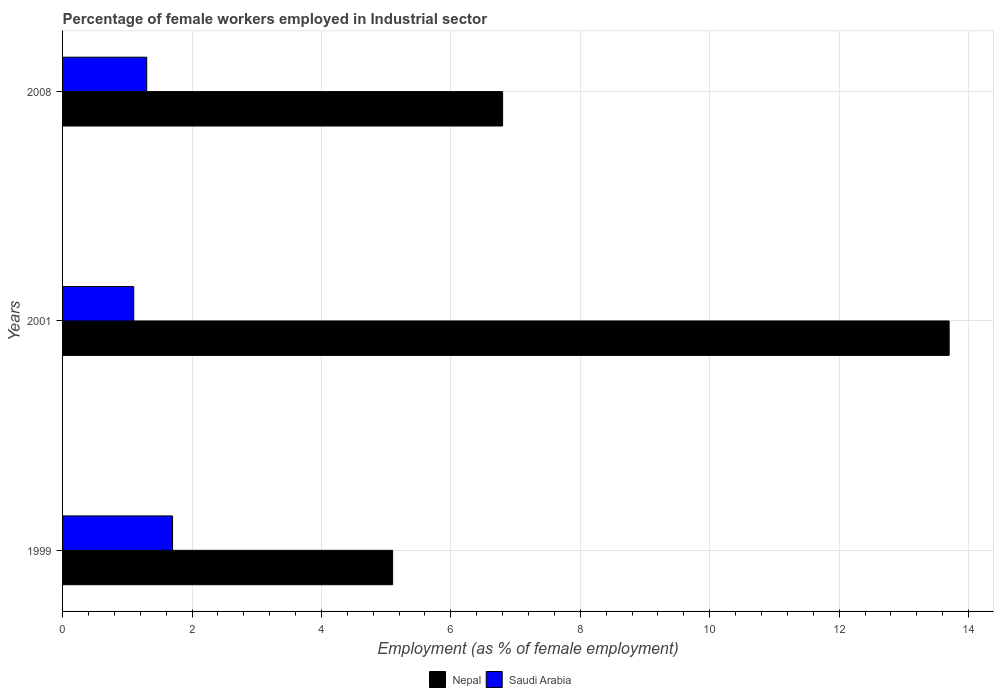How many different coloured bars are there?
Provide a succinct answer. 2. How many groups of bars are there?
Make the answer very short. 3. Are the number of bars per tick equal to the number of legend labels?
Make the answer very short. Yes. Are the number of bars on each tick of the Y-axis equal?
Offer a terse response. Yes. How many bars are there on the 2nd tick from the top?
Your answer should be compact. 2. How many bars are there on the 1st tick from the bottom?
Your answer should be very brief. 2. What is the label of the 3rd group of bars from the top?
Ensure brevity in your answer.  1999. In how many cases, is the number of bars for a given year not equal to the number of legend labels?
Your answer should be compact. 0. What is the percentage of females employed in Industrial sector in Saudi Arabia in 2008?
Your response must be concise. 1.3. Across all years, what is the maximum percentage of females employed in Industrial sector in Nepal?
Your answer should be compact. 13.7. Across all years, what is the minimum percentage of females employed in Industrial sector in Nepal?
Keep it short and to the point. 5.1. In which year was the percentage of females employed in Industrial sector in Nepal minimum?
Your answer should be compact. 1999. What is the total percentage of females employed in Industrial sector in Saudi Arabia in the graph?
Ensure brevity in your answer.  4.1. What is the difference between the percentage of females employed in Industrial sector in Saudi Arabia in 1999 and that in 2001?
Offer a terse response. 0.6. What is the difference between the percentage of females employed in Industrial sector in Saudi Arabia in 2008 and the percentage of females employed in Industrial sector in Nepal in 2001?
Give a very brief answer. -12.4. What is the average percentage of females employed in Industrial sector in Nepal per year?
Your answer should be very brief. 8.53. In the year 2008, what is the difference between the percentage of females employed in Industrial sector in Nepal and percentage of females employed in Industrial sector in Saudi Arabia?
Keep it short and to the point. 5.5. In how many years, is the percentage of females employed in Industrial sector in Saudi Arabia greater than 1.2000000000000002 %?
Provide a short and direct response. 2. What is the ratio of the percentage of females employed in Industrial sector in Saudi Arabia in 1999 to that in 2008?
Provide a succinct answer. 1.31. What is the difference between the highest and the second highest percentage of females employed in Industrial sector in Saudi Arabia?
Give a very brief answer. 0.4. What is the difference between the highest and the lowest percentage of females employed in Industrial sector in Nepal?
Your answer should be very brief. 8.6. Is the sum of the percentage of females employed in Industrial sector in Nepal in 2001 and 2008 greater than the maximum percentage of females employed in Industrial sector in Saudi Arabia across all years?
Offer a very short reply. Yes. What does the 2nd bar from the top in 2008 represents?
Provide a short and direct response. Nepal. What does the 1st bar from the bottom in 2008 represents?
Give a very brief answer. Nepal. How many bars are there?
Keep it short and to the point. 6. Are the values on the major ticks of X-axis written in scientific E-notation?
Provide a succinct answer. No. Does the graph contain any zero values?
Your response must be concise. No. Does the graph contain grids?
Your response must be concise. Yes. What is the title of the graph?
Offer a terse response. Percentage of female workers employed in Industrial sector. Does "Korea (Democratic)" appear as one of the legend labels in the graph?
Keep it short and to the point. No. What is the label or title of the X-axis?
Provide a succinct answer. Employment (as % of female employment). What is the label or title of the Y-axis?
Keep it short and to the point. Years. What is the Employment (as % of female employment) of Nepal in 1999?
Give a very brief answer. 5.1. What is the Employment (as % of female employment) of Saudi Arabia in 1999?
Give a very brief answer. 1.7. What is the Employment (as % of female employment) of Nepal in 2001?
Make the answer very short. 13.7. What is the Employment (as % of female employment) in Saudi Arabia in 2001?
Ensure brevity in your answer.  1.1. What is the Employment (as % of female employment) in Nepal in 2008?
Provide a short and direct response. 6.8. What is the Employment (as % of female employment) of Saudi Arabia in 2008?
Offer a very short reply. 1.3. Across all years, what is the maximum Employment (as % of female employment) of Nepal?
Your answer should be compact. 13.7. Across all years, what is the maximum Employment (as % of female employment) of Saudi Arabia?
Offer a very short reply. 1.7. Across all years, what is the minimum Employment (as % of female employment) of Nepal?
Your answer should be very brief. 5.1. Across all years, what is the minimum Employment (as % of female employment) in Saudi Arabia?
Provide a short and direct response. 1.1. What is the total Employment (as % of female employment) in Nepal in the graph?
Your response must be concise. 25.6. What is the total Employment (as % of female employment) of Saudi Arabia in the graph?
Give a very brief answer. 4.1. What is the difference between the Employment (as % of female employment) in Saudi Arabia in 1999 and that in 2001?
Your answer should be very brief. 0.6. What is the difference between the Employment (as % of female employment) of Nepal in 1999 and that in 2008?
Provide a succinct answer. -1.7. What is the difference between the Employment (as % of female employment) of Saudi Arabia in 2001 and that in 2008?
Make the answer very short. -0.2. What is the difference between the Employment (as % of female employment) in Nepal in 1999 and the Employment (as % of female employment) in Saudi Arabia in 2001?
Keep it short and to the point. 4. What is the average Employment (as % of female employment) in Nepal per year?
Give a very brief answer. 8.53. What is the average Employment (as % of female employment) of Saudi Arabia per year?
Ensure brevity in your answer.  1.37. In the year 1999, what is the difference between the Employment (as % of female employment) in Nepal and Employment (as % of female employment) in Saudi Arabia?
Give a very brief answer. 3.4. In the year 2001, what is the difference between the Employment (as % of female employment) in Nepal and Employment (as % of female employment) in Saudi Arabia?
Offer a very short reply. 12.6. What is the ratio of the Employment (as % of female employment) in Nepal in 1999 to that in 2001?
Give a very brief answer. 0.37. What is the ratio of the Employment (as % of female employment) in Saudi Arabia in 1999 to that in 2001?
Your answer should be very brief. 1.55. What is the ratio of the Employment (as % of female employment) in Saudi Arabia in 1999 to that in 2008?
Your response must be concise. 1.31. What is the ratio of the Employment (as % of female employment) of Nepal in 2001 to that in 2008?
Offer a very short reply. 2.01. What is the ratio of the Employment (as % of female employment) in Saudi Arabia in 2001 to that in 2008?
Provide a succinct answer. 0.85. What is the difference between the highest and the second highest Employment (as % of female employment) in Saudi Arabia?
Provide a succinct answer. 0.4. What is the difference between the highest and the lowest Employment (as % of female employment) in Nepal?
Keep it short and to the point. 8.6. 